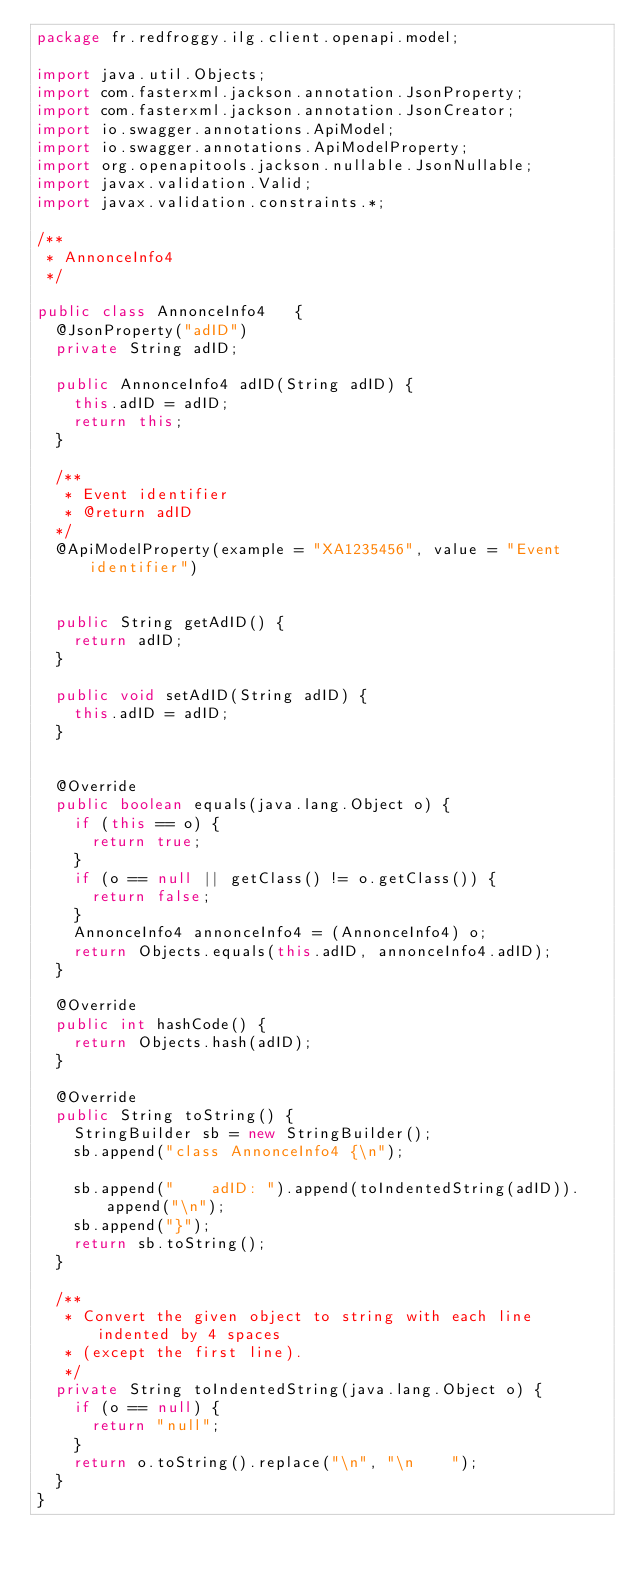Convert code to text. <code><loc_0><loc_0><loc_500><loc_500><_Java_>package fr.redfroggy.ilg.client.openapi.model;

import java.util.Objects;
import com.fasterxml.jackson.annotation.JsonProperty;
import com.fasterxml.jackson.annotation.JsonCreator;
import io.swagger.annotations.ApiModel;
import io.swagger.annotations.ApiModelProperty;
import org.openapitools.jackson.nullable.JsonNullable;
import javax.validation.Valid;
import javax.validation.constraints.*;

/**
 * AnnonceInfo4
 */

public class AnnonceInfo4   {
  @JsonProperty("adID")
  private String adID;

  public AnnonceInfo4 adID(String adID) {
    this.adID = adID;
    return this;
  }

  /**
   * Event identifier
   * @return adID
  */
  @ApiModelProperty(example = "XA1235456", value = "Event identifier")


  public String getAdID() {
    return adID;
  }

  public void setAdID(String adID) {
    this.adID = adID;
  }


  @Override
  public boolean equals(java.lang.Object o) {
    if (this == o) {
      return true;
    }
    if (o == null || getClass() != o.getClass()) {
      return false;
    }
    AnnonceInfo4 annonceInfo4 = (AnnonceInfo4) o;
    return Objects.equals(this.adID, annonceInfo4.adID);
  }

  @Override
  public int hashCode() {
    return Objects.hash(adID);
  }

  @Override
  public String toString() {
    StringBuilder sb = new StringBuilder();
    sb.append("class AnnonceInfo4 {\n");
    
    sb.append("    adID: ").append(toIndentedString(adID)).append("\n");
    sb.append("}");
    return sb.toString();
  }

  /**
   * Convert the given object to string with each line indented by 4 spaces
   * (except the first line).
   */
  private String toIndentedString(java.lang.Object o) {
    if (o == null) {
      return "null";
    }
    return o.toString().replace("\n", "\n    ");
  }
}

</code> 